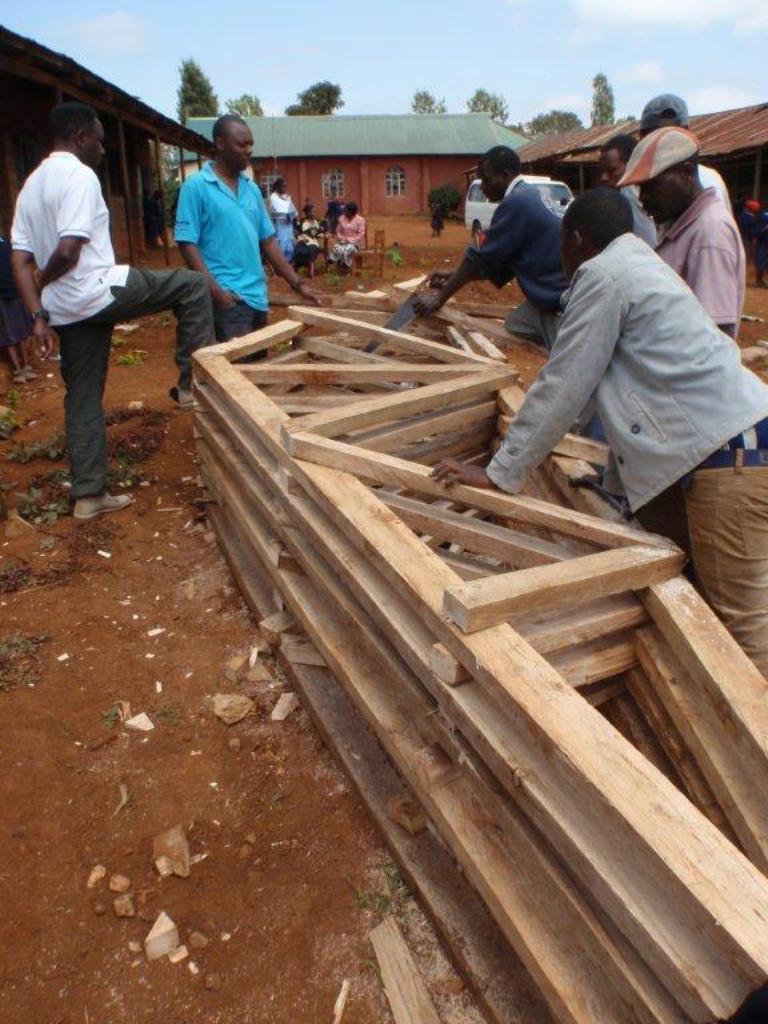Could you give a brief overview of what you see in this image? In this image I can see some people are doing something with the wood. In the background, I can see the trees and clouds in the sky. 